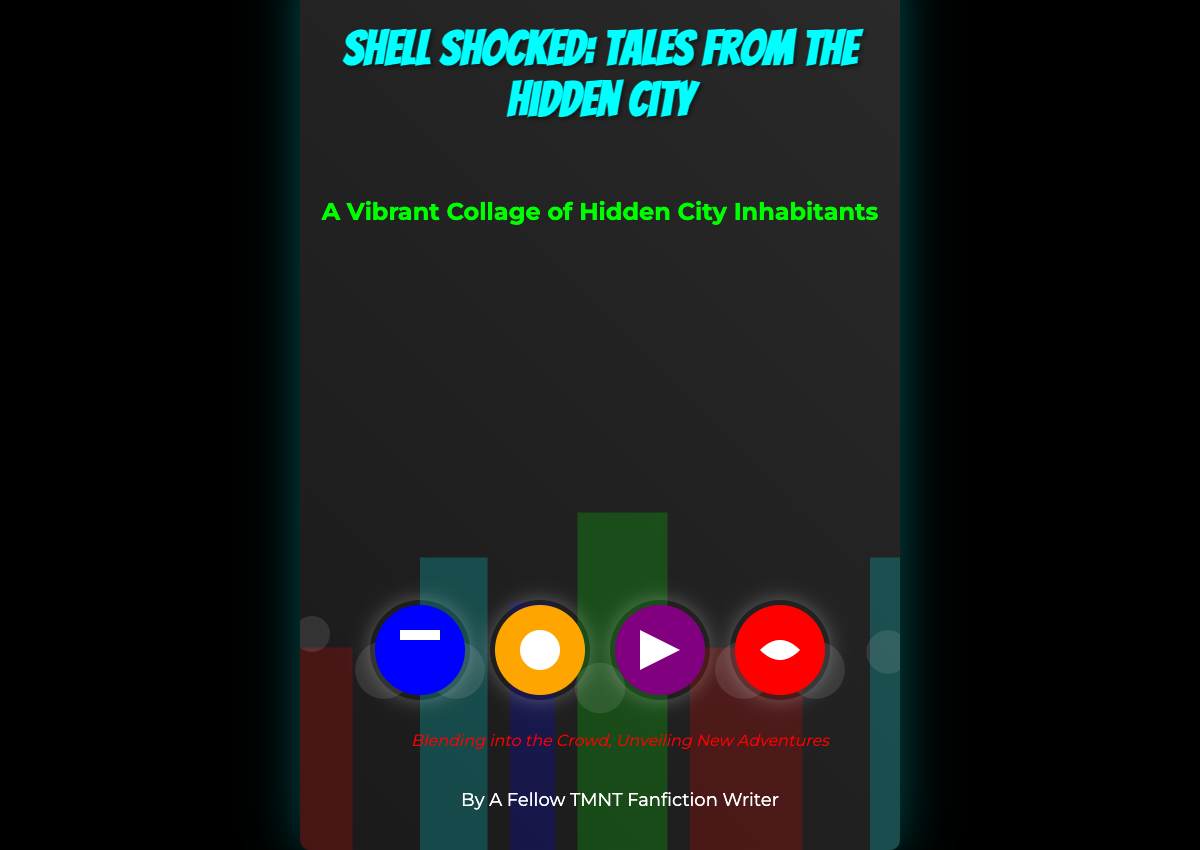What is the title of the book? The title is displayed prominently at the top of the book cover in a large font.
Answer: Shell Shocked: Tales from the Hidden City Who is the author of the book? The author's name is located at the bottom of the cover.
Answer: A Fellow TMNT Fanfiction Writer What color is Leonardo's mask? The mask color can be identified from the turtle representation in the cover graphics.
Answer: Blue What phrase is used as the tagline? The tagline is displayed prominently in a different font style near the bottom of the cover.
Answer: Blending into the Crowd, Unveiling New Adventures How many turtles are illustrated on the cover? The number of turtles can be counted from their representations on the cover.
Answer: Four What type of inhabitants are depicted on the cover? The subtitle provides information about the characters represented in the artwork.
Answer: Diverse inhabitants What is the dominant background color of the book cover? The primary background color is indicated in the style settings of the document.
Answer: Black What visual effect is used for the cityscape? The style settings mention effects applied to the cityscape background.
Answer: Opacity What font is used for the title? The style settings specify the font family for the title display.
Answer: Bangers 